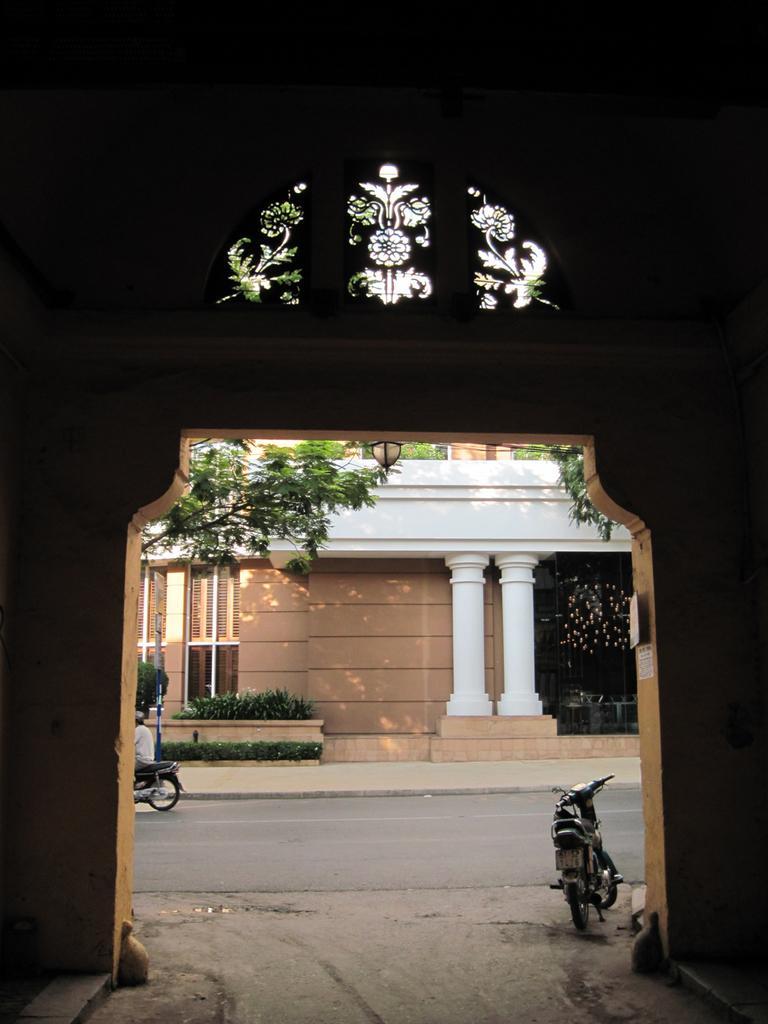Describe this image in one or two sentences. In this image we can see an arch. To the right side of the image we can see a vehicle parked on the ground. On the left side of the image we can see a person riding a bike. In the background, we can see a building with pillars, group of trees and trees. 